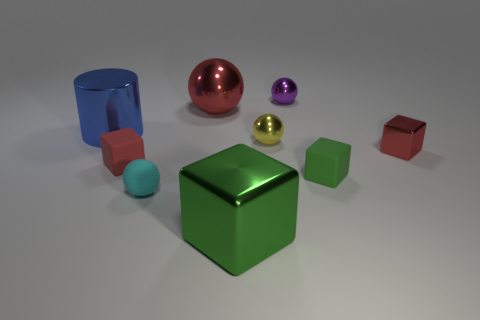Are there any other things that are the same shape as the large blue shiny thing?
Your response must be concise. No. What size is the shiny object that is both left of the tiny yellow metallic ball and in front of the big cylinder?
Give a very brief answer. Large. How many things are either large brown cylinders or tiny matte things?
Give a very brief answer. 3. Do the red sphere and the red shiny object that is in front of the big blue cylinder have the same size?
Ensure brevity in your answer.  No. There is a metallic object that is in front of the green block that is to the right of the small metal sphere that is behind the large metal cylinder; how big is it?
Provide a short and direct response. Large. Is there a green thing?
Offer a very short reply. Yes. There is a small object that is the same color as the large block; what is it made of?
Offer a very short reply. Rubber. What number of tiny things have the same color as the cylinder?
Offer a very short reply. 0. How many objects are small objects to the right of the large metallic block or red things on the right side of the big metal block?
Offer a terse response. 4. There is a tiny metallic thing that is in front of the small yellow sphere; what number of tiny red metal things are on the right side of it?
Offer a very short reply. 0. 